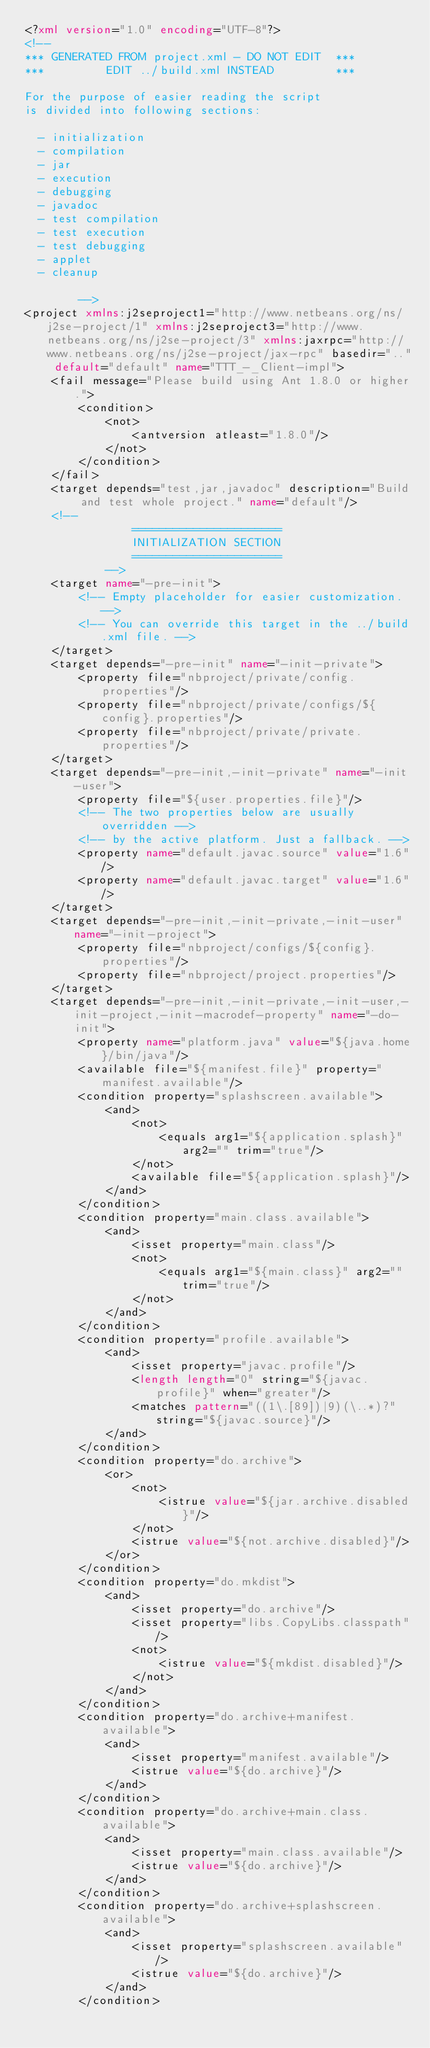<code> <loc_0><loc_0><loc_500><loc_500><_XML_><?xml version="1.0" encoding="UTF-8"?>
<!--
*** GENERATED FROM project.xml - DO NOT EDIT  ***
***         EDIT ../build.xml INSTEAD         ***

For the purpose of easier reading the script
is divided into following sections:

  - initialization
  - compilation
  - jar
  - execution
  - debugging
  - javadoc
  - test compilation
  - test execution
  - test debugging
  - applet
  - cleanup

        -->
<project xmlns:j2seproject1="http://www.netbeans.org/ns/j2se-project/1" xmlns:j2seproject3="http://www.netbeans.org/ns/j2se-project/3" xmlns:jaxrpc="http://www.netbeans.org/ns/j2se-project/jax-rpc" basedir=".." default="default" name="TTT_-_Client-impl">
    <fail message="Please build using Ant 1.8.0 or higher.">
        <condition>
            <not>
                <antversion atleast="1.8.0"/>
            </not>
        </condition>
    </fail>
    <target depends="test,jar,javadoc" description="Build and test whole project." name="default"/>
    <!-- 
                ======================
                INITIALIZATION SECTION 
                ======================
            -->
    <target name="-pre-init">
        <!-- Empty placeholder for easier customization. -->
        <!-- You can override this target in the ../build.xml file. -->
    </target>
    <target depends="-pre-init" name="-init-private">
        <property file="nbproject/private/config.properties"/>
        <property file="nbproject/private/configs/${config}.properties"/>
        <property file="nbproject/private/private.properties"/>
    </target>
    <target depends="-pre-init,-init-private" name="-init-user">
        <property file="${user.properties.file}"/>
        <!-- The two properties below are usually overridden -->
        <!-- by the active platform. Just a fallback. -->
        <property name="default.javac.source" value="1.6"/>
        <property name="default.javac.target" value="1.6"/>
    </target>
    <target depends="-pre-init,-init-private,-init-user" name="-init-project">
        <property file="nbproject/configs/${config}.properties"/>
        <property file="nbproject/project.properties"/>
    </target>
    <target depends="-pre-init,-init-private,-init-user,-init-project,-init-macrodef-property" name="-do-init">
        <property name="platform.java" value="${java.home}/bin/java"/>
        <available file="${manifest.file}" property="manifest.available"/>
        <condition property="splashscreen.available">
            <and>
                <not>
                    <equals arg1="${application.splash}" arg2="" trim="true"/>
                </not>
                <available file="${application.splash}"/>
            </and>
        </condition>
        <condition property="main.class.available">
            <and>
                <isset property="main.class"/>
                <not>
                    <equals arg1="${main.class}" arg2="" trim="true"/>
                </not>
            </and>
        </condition>
        <condition property="profile.available">
            <and>
                <isset property="javac.profile"/>
                <length length="0" string="${javac.profile}" when="greater"/>
                <matches pattern="((1\.[89])|9)(\..*)?" string="${javac.source}"/>
            </and>
        </condition>
        <condition property="do.archive">
            <or>
                <not>
                    <istrue value="${jar.archive.disabled}"/>
                </not>
                <istrue value="${not.archive.disabled}"/>
            </or>
        </condition>
        <condition property="do.mkdist">
            <and>
                <isset property="do.archive"/>
                <isset property="libs.CopyLibs.classpath"/>
                <not>
                    <istrue value="${mkdist.disabled}"/>
                </not>
            </and>
        </condition>
        <condition property="do.archive+manifest.available">
            <and>
                <isset property="manifest.available"/>
                <istrue value="${do.archive}"/>
            </and>
        </condition>
        <condition property="do.archive+main.class.available">
            <and>
                <isset property="main.class.available"/>
                <istrue value="${do.archive}"/>
            </and>
        </condition>
        <condition property="do.archive+splashscreen.available">
            <and>
                <isset property="splashscreen.available"/>
                <istrue value="${do.archive}"/>
            </and>
        </condition></code> 